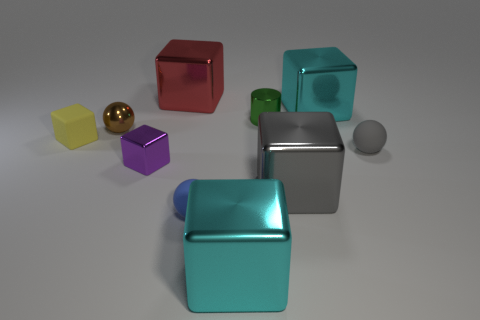Subtract 2 cubes. How many cubes are left? 4 Subtract all yellow cubes. How many cubes are left? 5 Subtract all cyan metal blocks. How many blocks are left? 4 Subtract all yellow blocks. Subtract all blue spheres. How many blocks are left? 5 Subtract all balls. How many objects are left? 7 Subtract all brown objects. Subtract all big metal things. How many objects are left? 5 Add 3 small gray matte things. How many small gray matte things are left? 4 Add 4 large purple things. How many large purple things exist? 4 Subtract 1 gray spheres. How many objects are left? 9 